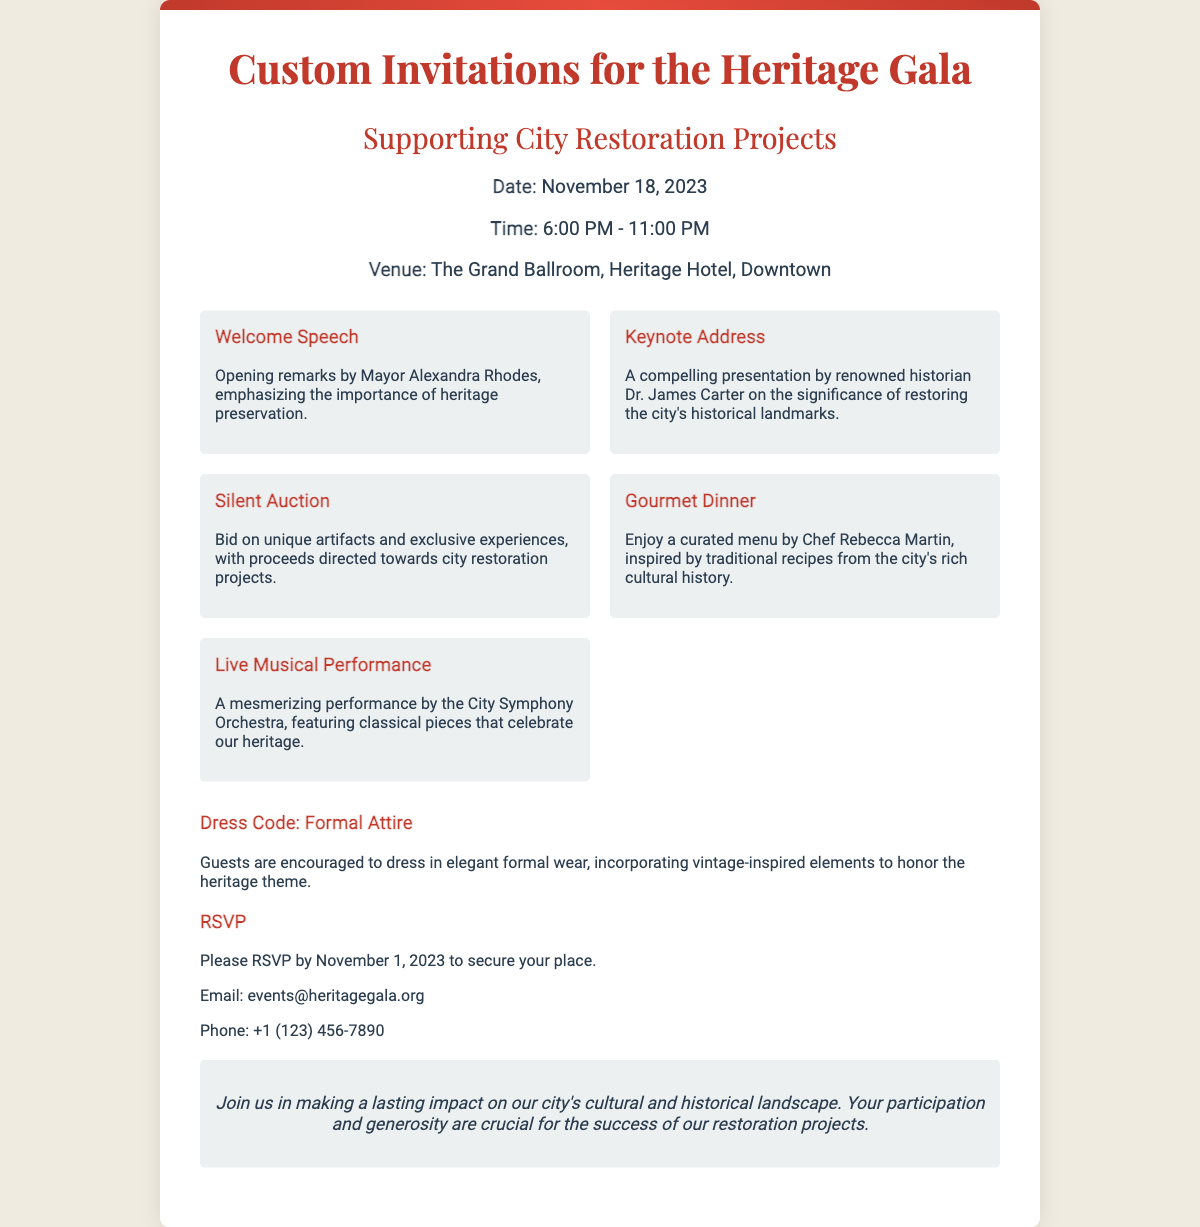What is the date of the Heritage Gala? The date of the Heritage Gala is clearly mentioned in the document, which states it is on November 18, 2023.
Answer: November 18, 2023 What time does the event start? The document provides the event's start time as part of the event details, which states it begins at 6:00 PM.
Answer: 6:00 PM Who is delivering the keynote address? The document names the speaker of the keynote address as Dr. James Carter, focusing on historical preservation.
Answer: Dr. James Carter What type of dinner will guests enjoy? A gourmet dinner is highlighted in the document, specifying that it features a curated menu inspired by traditional recipes.
Answer: Gourmet Dinner What is the dress code for the event? The dress code section in the document explicitly states that guests are required to wear formal attire.
Answer: Formal Attire When is the RSVP deadline? The document clearly mentions that RSVPs must be received by November 1, 2023.
Answer: November 1, 2023 What will the guests be able to bid on? The document includes a section on the silent auction, mentioning unique artifacts and exclusive experiences available for bidding.
Answer: Unique artifacts and exclusive experiences What is the main purpose of the Heritage Gala? The document emphasizes that the gala supports city restoration projects, indicating its primary goal is preservation efforts.
Answer: Supporting City Restoration Projects What style of musical performance is included in the event? The event details in the document describe a live musical performance by the City Symphony Orchestra, focusing on classical pieces.
Answer: Classical pieces 